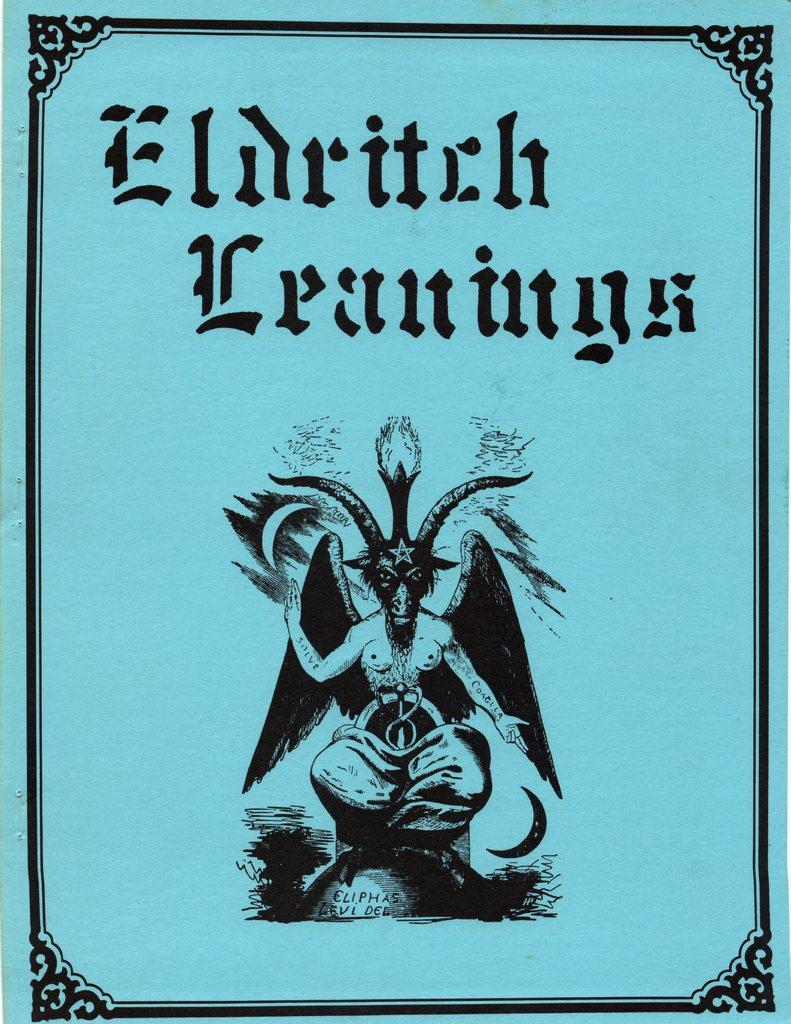<image>
Offer a succinct explanation of the picture presented. a blue poster with a title that says 'eldritch leanings' 